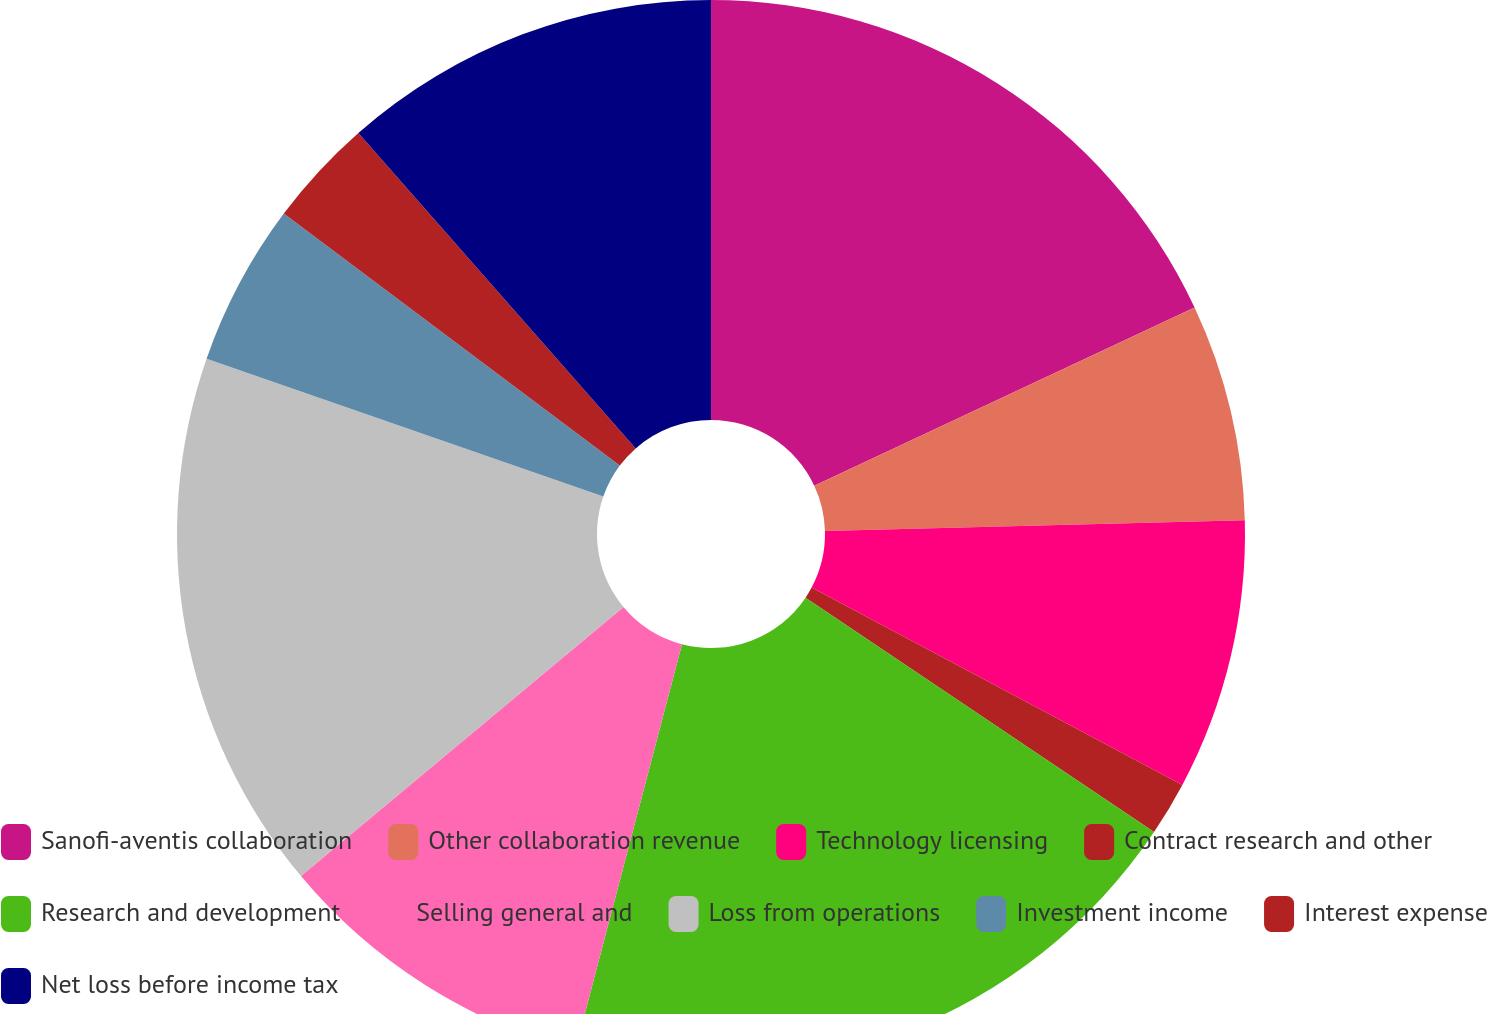Convert chart to OTSL. <chart><loc_0><loc_0><loc_500><loc_500><pie_chart><fcel>Sanofi-aventis collaboration<fcel>Other collaboration revenue<fcel>Technology licensing<fcel>Contract research and other<fcel>Research and development<fcel>Selling general and<fcel>Loss from operations<fcel>Investment income<fcel>Interest expense<fcel>Net loss before income tax<nl><fcel>18.03%<fcel>6.56%<fcel>8.2%<fcel>1.64%<fcel>19.67%<fcel>9.84%<fcel>16.39%<fcel>4.92%<fcel>3.28%<fcel>11.48%<nl></chart> 